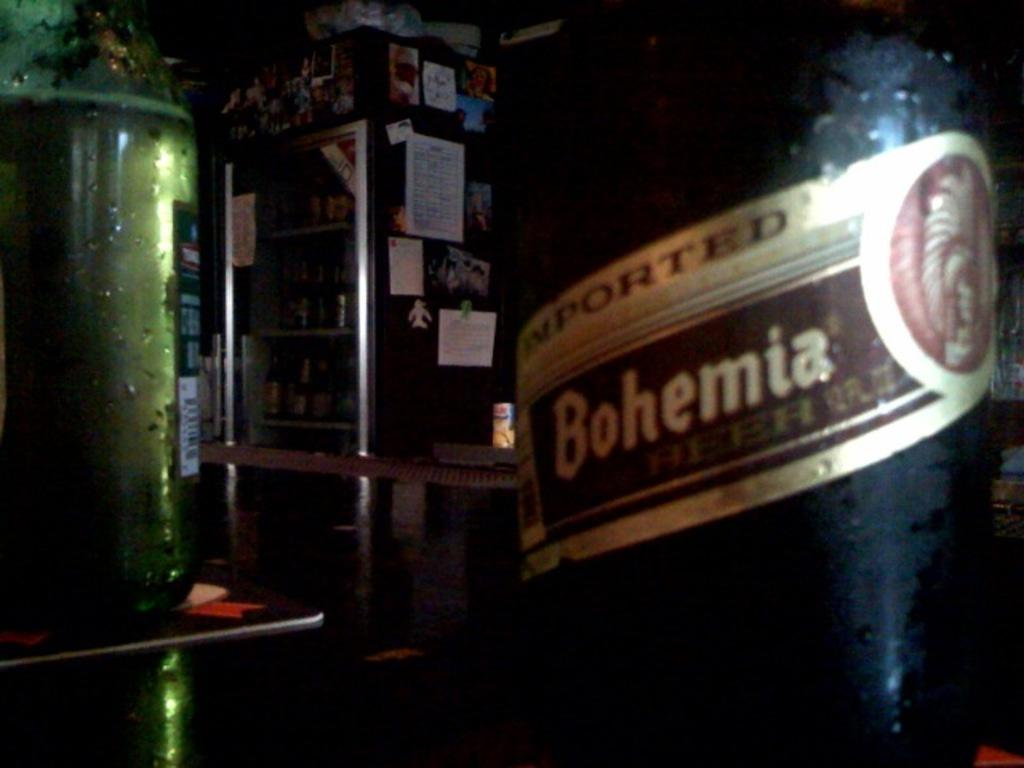<image>
Offer a succinct explanation of the picture presented. A Bohemia beer bottle on a bar counter. 